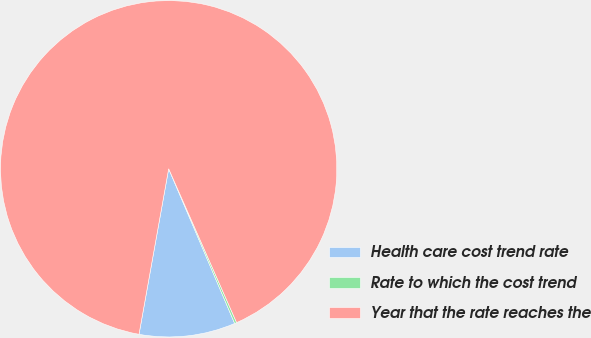Convert chart to OTSL. <chart><loc_0><loc_0><loc_500><loc_500><pie_chart><fcel>Health care cost trend rate<fcel>Rate to which the cost trend<fcel>Year that the rate reaches the<nl><fcel>9.24%<fcel>0.2%<fcel>90.56%<nl></chart> 